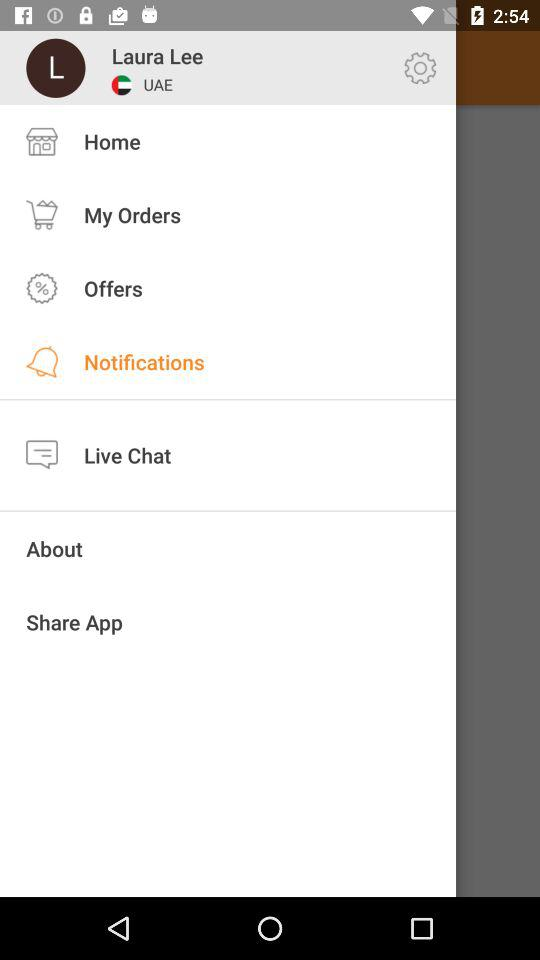What is the user's country? The user's country is the United Arab Emirates. 